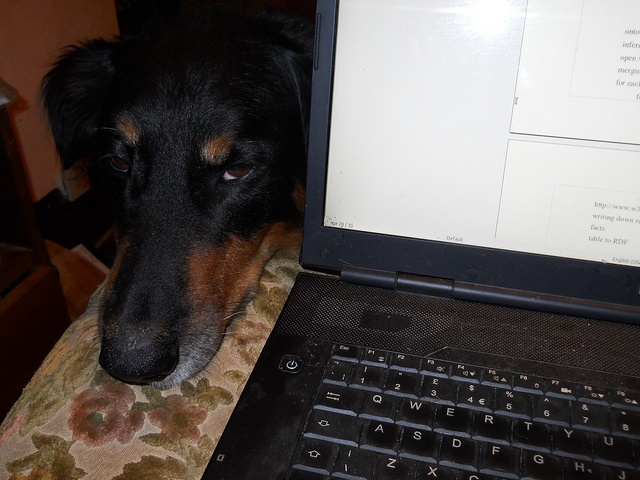Describe the objects in this image and their specific colors. I can see laptop in maroon, black, white, and gray tones and dog in maroon, black, and gray tones in this image. 